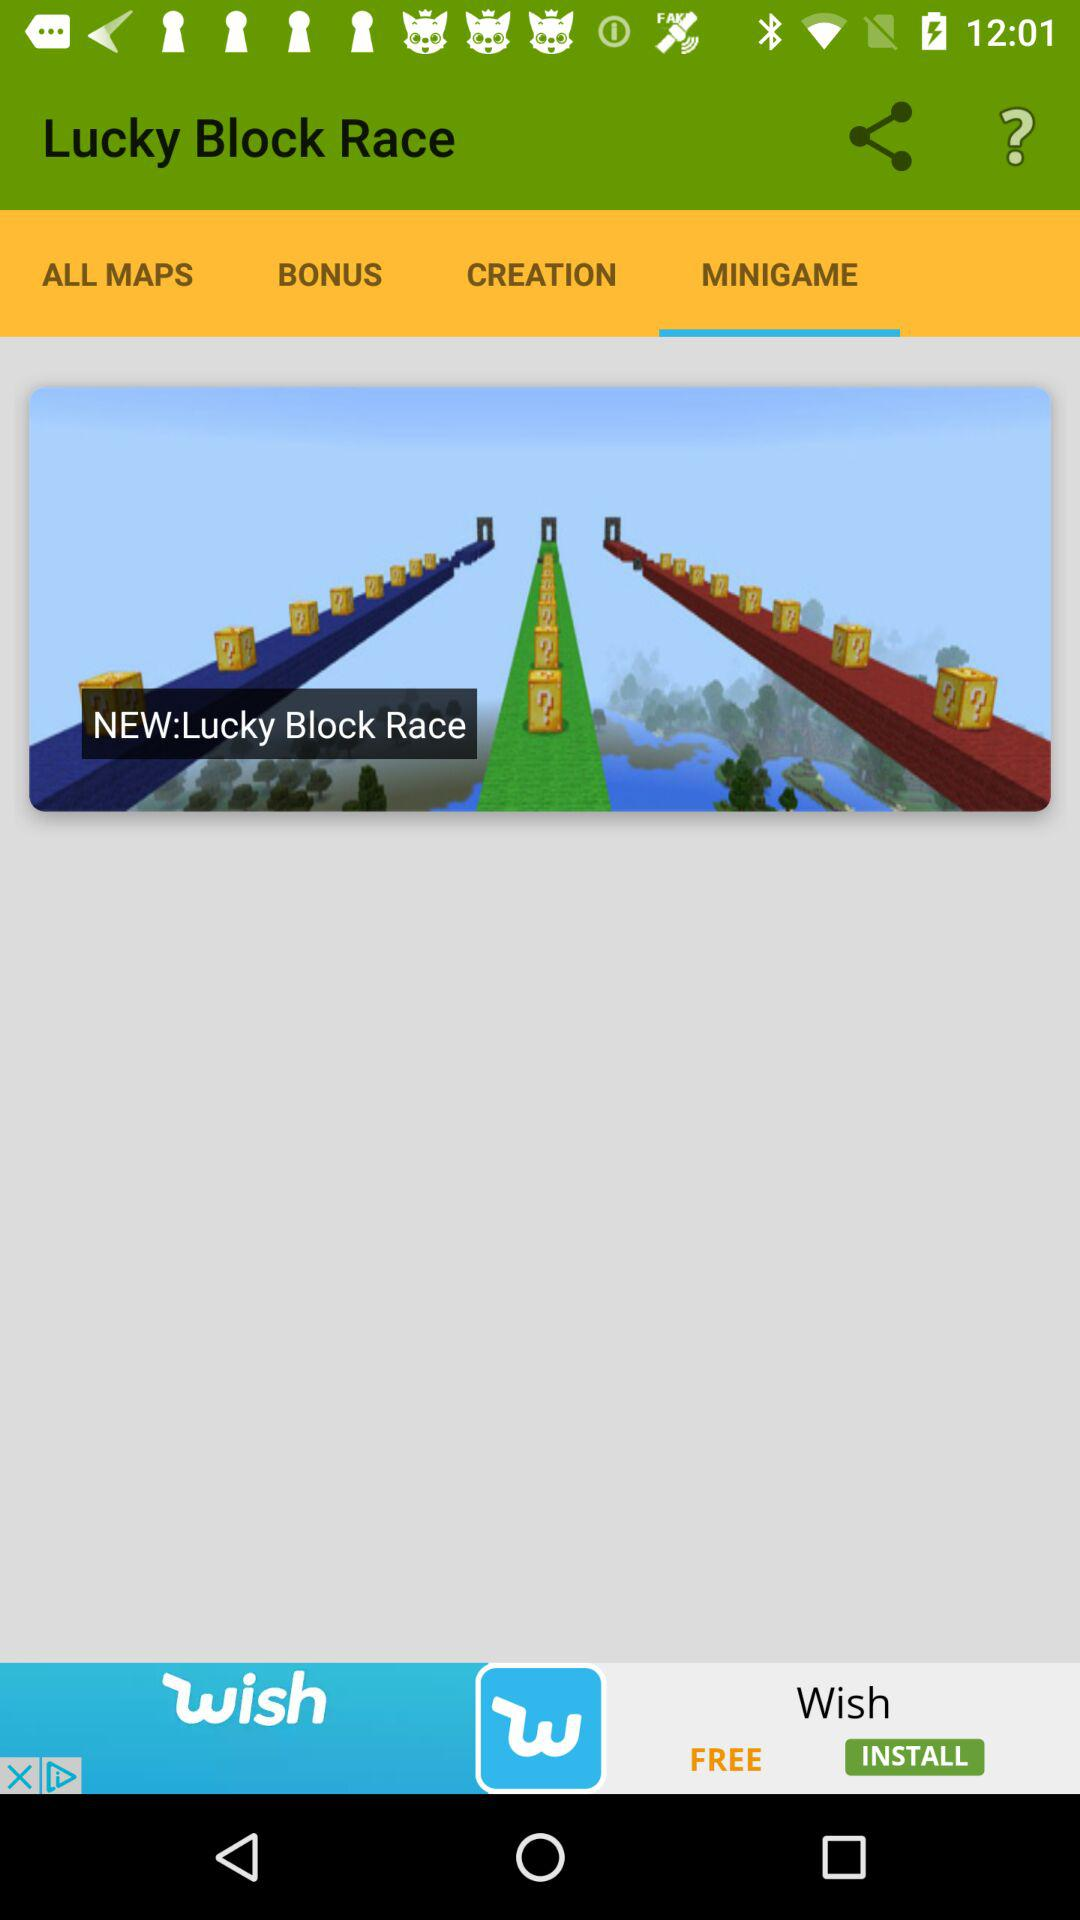Which tab is selected? The selected tab is "MINIGAME". 